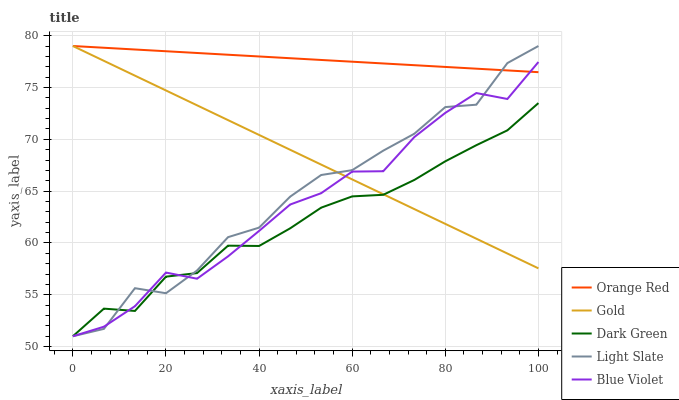Does Dark Green have the minimum area under the curve?
Answer yes or no. Yes. Does Orange Red have the maximum area under the curve?
Answer yes or no. Yes. Does Blue Violet have the minimum area under the curve?
Answer yes or no. No. Does Blue Violet have the maximum area under the curve?
Answer yes or no. No. Is Orange Red the smoothest?
Answer yes or no. Yes. Is Light Slate the roughest?
Answer yes or no. Yes. Is Blue Violet the smoothest?
Answer yes or no. No. Is Blue Violet the roughest?
Answer yes or no. No. Does Orange Red have the lowest value?
Answer yes or no. No. Does Gold have the highest value?
Answer yes or no. Yes. Does Blue Violet have the highest value?
Answer yes or no. No. Is Dark Green less than Orange Red?
Answer yes or no. Yes. Is Orange Red greater than Dark Green?
Answer yes or no. Yes. Does Dark Green intersect Orange Red?
Answer yes or no. No. 